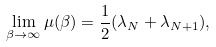Convert formula to latex. <formula><loc_0><loc_0><loc_500><loc_500>\lim _ { \beta \to \infty } \mu ( \beta ) = \frac { 1 } { 2 } ( \lambda _ { N } + \lambda _ { N + 1 } ) ,</formula> 